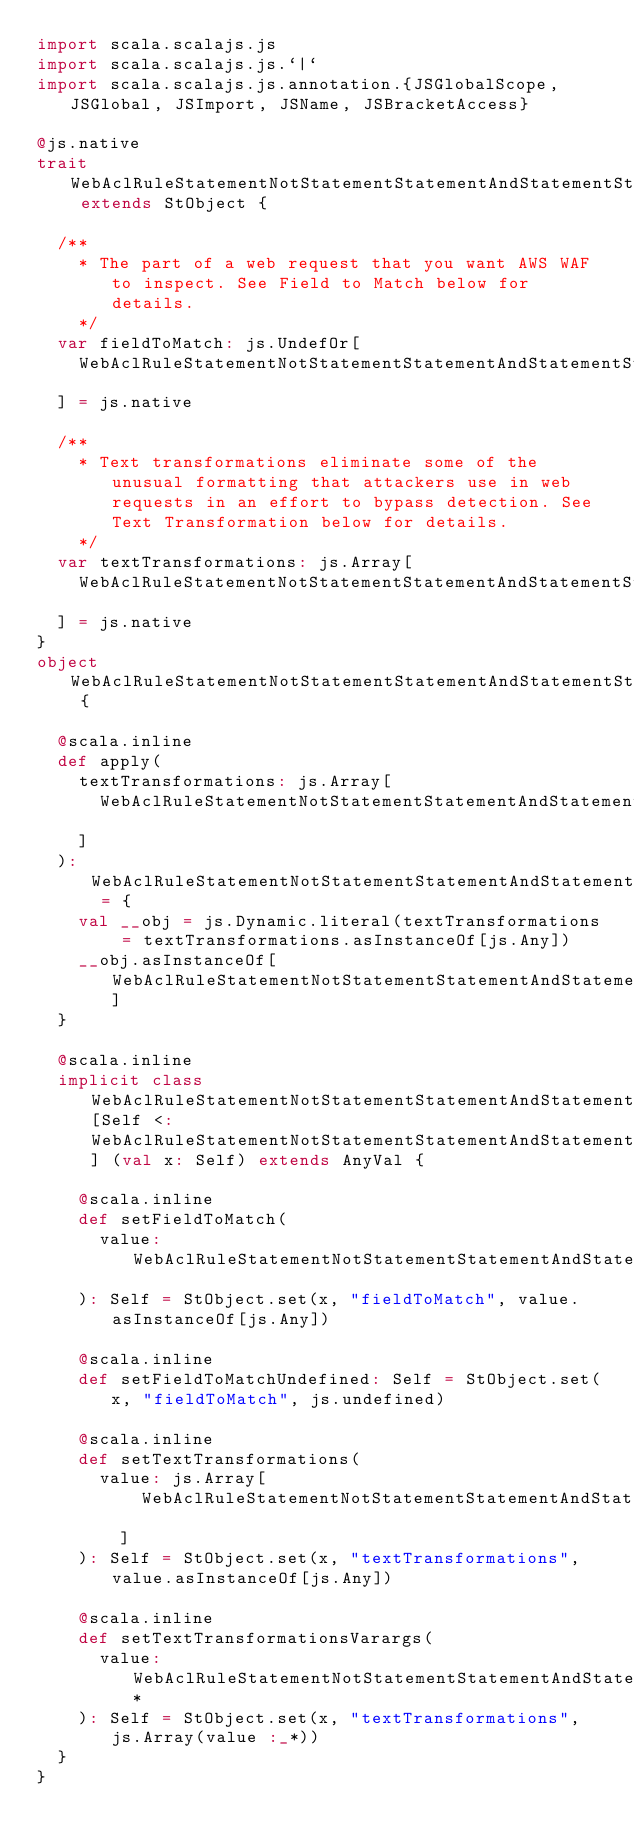Convert code to text. <code><loc_0><loc_0><loc_500><loc_500><_Scala_>import scala.scalajs.js
import scala.scalajs.js.`|`
import scala.scalajs.js.annotation.{JSGlobalScope, JSGlobal, JSImport, JSName, JSBracketAccess}

@js.native
trait WebAclRuleStatementNotStatementStatementAndStatementStatementAndStatementStatementSqliMatchStatement extends StObject {
  
  /**
    * The part of a web request that you want AWS WAF to inspect. See Field to Match below for details.
    */
  var fieldToMatch: js.UndefOr[
    WebAclRuleStatementNotStatementStatementAndStatementStatementAndStatementStatementSqliMatchStatementFieldToMatch
  ] = js.native
  
  /**
    * Text transformations eliminate some of the unusual formatting that attackers use in web requests in an effort to bypass detection. See Text Transformation below for details.
    */
  var textTransformations: js.Array[
    WebAclRuleStatementNotStatementStatementAndStatementStatementAndStatementStatementSqliMatchStatementTextTransformation
  ] = js.native
}
object WebAclRuleStatementNotStatementStatementAndStatementStatementAndStatementStatementSqliMatchStatement {
  
  @scala.inline
  def apply(
    textTransformations: js.Array[
      WebAclRuleStatementNotStatementStatementAndStatementStatementAndStatementStatementSqliMatchStatementTextTransformation
    ]
  ): WebAclRuleStatementNotStatementStatementAndStatementStatementAndStatementStatementSqliMatchStatement = {
    val __obj = js.Dynamic.literal(textTransformations = textTransformations.asInstanceOf[js.Any])
    __obj.asInstanceOf[WebAclRuleStatementNotStatementStatementAndStatementStatementAndStatementStatementSqliMatchStatement]
  }
  
  @scala.inline
  implicit class WebAclRuleStatementNotStatementStatementAndStatementStatementAndStatementStatementSqliMatchStatementMutableBuilder[Self <: WebAclRuleStatementNotStatementStatementAndStatementStatementAndStatementStatementSqliMatchStatement] (val x: Self) extends AnyVal {
    
    @scala.inline
    def setFieldToMatch(
      value: WebAclRuleStatementNotStatementStatementAndStatementStatementAndStatementStatementSqliMatchStatementFieldToMatch
    ): Self = StObject.set(x, "fieldToMatch", value.asInstanceOf[js.Any])
    
    @scala.inline
    def setFieldToMatchUndefined: Self = StObject.set(x, "fieldToMatch", js.undefined)
    
    @scala.inline
    def setTextTransformations(
      value: js.Array[
          WebAclRuleStatementNotStatementStatementAndStatementStatementAndStatementStatementSqliMatchStatementTextTransformation
        ]
    ): Self = StObject.set(x, "textTransformations", value.asInstanceOf[js.Any])
    
    @scala.inline
    def setTextTransformationsVarargs(
      value: WebAclRuleStatementNotStatementStatementAndStatementStatementAndStatementStatementSqliMatchStatementTextTransformation*
    ): Self = StObject.set(x, "textTransformations", js.Array(value :_*))
  }
}
</code> 